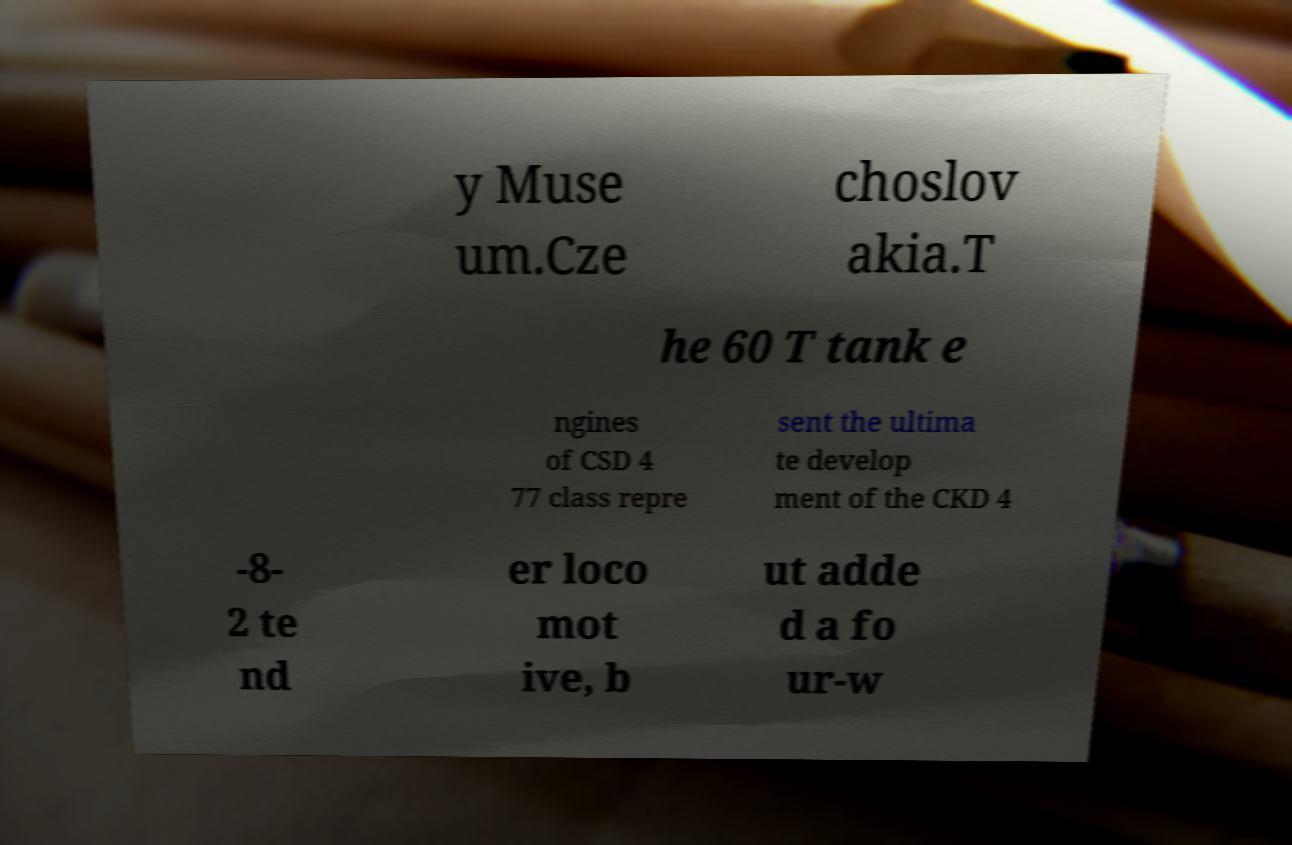There's text embedded in this image that I need extracted. Can you transcribe it verbatim? y Muse um.Cze choslov akia.T he 60 T tank e ngines of CSD 4 77 class repre sent the ultima te develop ment of the CKD 4 -8- 2 te nd er loco mot ive, b ut adde d a fo ur-w 